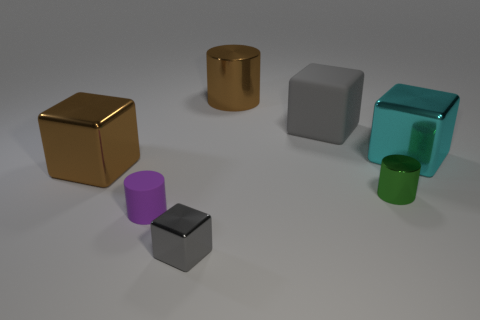Add 1 large gray shiny blocks. How many objects exist? 8 Subtract all cylinders. How many objects are left? 4 Subtract all tiny gray metal cubes. Subtract all gray shiny blocks. How many objects are left? 5 Add 5 gray things. How many gray things are left? 7 Add 1 brown metallic cubes. How many brown metallic cubes exist? 2 Subtract 0 red cylinders. How many objects are left? 7 